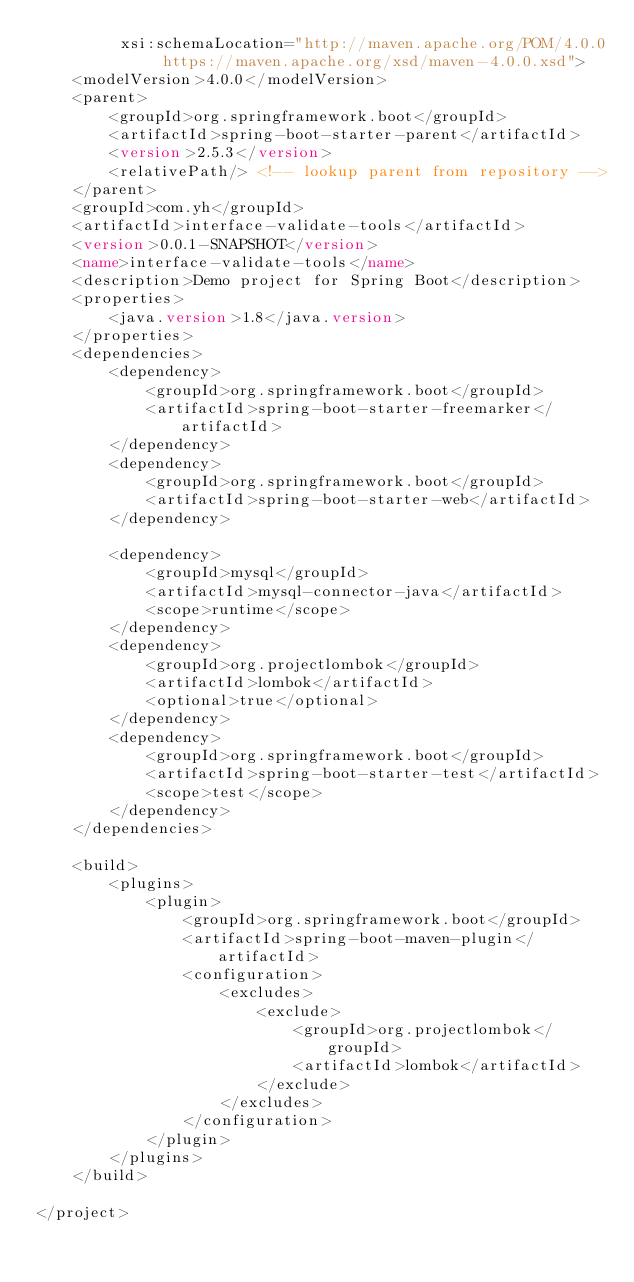Convert code to text. <code><loc_0><loc_0><loc_500><loc_500><_XML_>         xsi:schemaLocation="http://maven.apache.org/POM/4.0.0 https://maven.apache.org/xsd/maven-4.0.0.xsd">
    <modelVersion>4.0.0</modelVersion>
    <parent>
        <groupId>org.springframework.boot</groupId>
        <artifactId>spring-boot-starter-parent</artifactId>
        <version>2.5.3</version>
        <relativePath/> <!-- lookup parent from repository -->
    </parent>
    <groupId>com.yh</groupId>
    <artifactId>interface-validate-tools</artifactId>
    <version>0.0.1-SNAPSHOT</version>
    <name>interface-validate-tools</name>
    <description>Demo project for Spring Boot</description>
    <properties>
        <java.version>1.8</java.version>
    </properties>
    <dependencies>
        <dependency>
            <groupId>org.springframework.boot</groupId>
            <artifactId>spring-boot-starter-freemarker</artifactId>
        </dependency>
        <dependency>
            <groupId>org.springframework.boot</groupId>
            <artifactId>spring-boot-starter-web</artifactId>
        </dependency>

        <dependency>
            <groupId>mysql</groupId>
            <artifactId>mysql-connector-java</artifactId>
            <scope>runtime</scope>
        </dependency>
        <dependency>
            <groupId>org.projectlombok</groupId>
            <artifactId>lombok</artifactId>
            <optional>true</optional>
        </dependency>
        <dependency>
            <groupId>org.springframework.boot</groupId>
            <artifactId>spring-boot-starter-test</artifactId>
            <scope>test</scope>
        </dependency>
    </dependencies>

    <build>
        <plugins>
            <plugin>
                <groupId>org.springframework.boot</groupId>
                <artifactId>spring-boot-maven-plugin</artifactId>
                <configuration>
                    <excludes>
                        <exclude>
                            <groupId>org.projectlombok</groupId>
                            <artifactId>lombok</artifactId>
                        </exclude>
                    </excludes>
                </configuration>
            </plugin>
        </plugins>
    </build>

</project>
</code> 